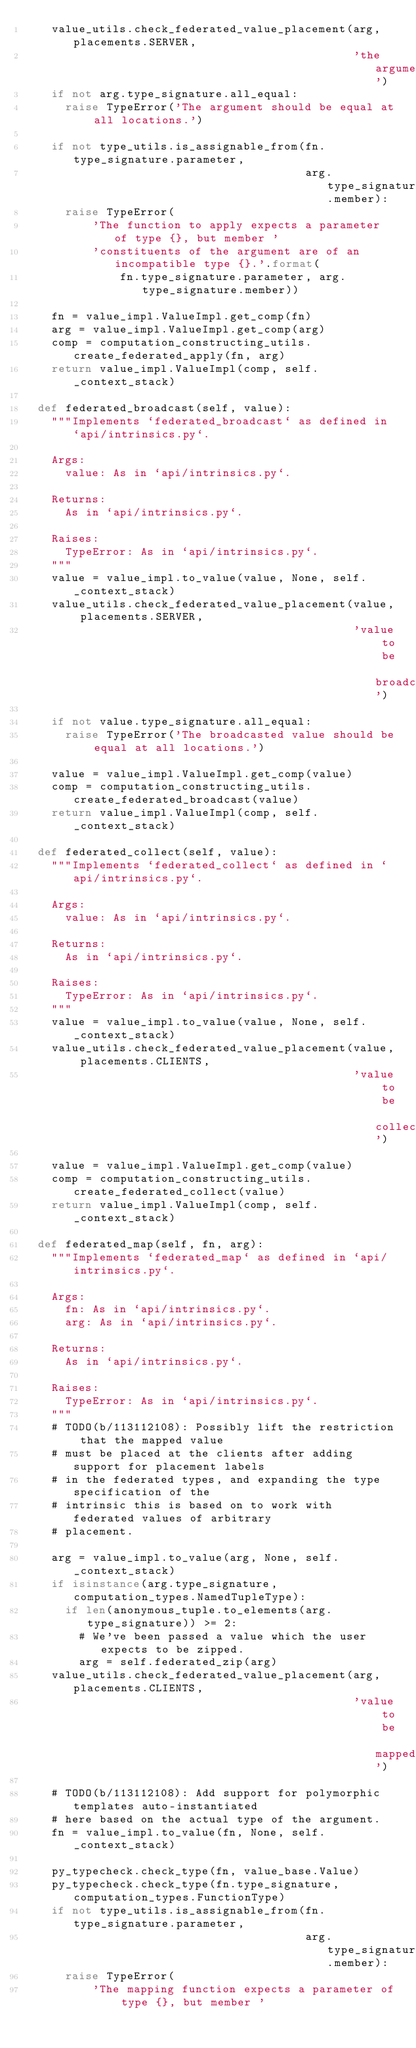<code> <loc_0><loc_0><loc_500><loc_500><_Python_>    value_utils.check_federated_value_placement(arg, placements.SERVER,
                                                'the argument')
    if not arg.type_signature.all_equal:
      raise TypeError('The argument should be equal at all locations.')

    if not type_utils.is_assignable_from(fn.type_signature.parameter,
                                         arg.type_signature.member):
      raise TypeError(
          'The function to apply expects a parameter of type {}, but member '
          'constituents of the argument are of an incompatible type {}.'.format(
              fn.type_signature.parameter, arg.type_signature.member))

    fn = value_impl.ValueImpl.get_comp(fn)
    arg = value_impl.ValueImpl.get_comp(arg)
    comp = computation_constructing_utils.create_federated_apply(fn, arg)
    return value_impl.ValueImpl(comp, self._context_stack)

  def federated_broadcast(self, value):
    """Implements `federated_broadcast` as defined in `api/intrinsics.py`.

    Args:
      value: As in `api/intrinsics.py`.

    Returns:
      As in `api/intrinsics.py`.

    Raises:
      TypeError: As in `api/intrinsics.py`.
    """
    value = value_impl.to_value(value, None, self._context_stack)
    value_utils.check_federated_value_placement(value, placements.SERVER,
                                                'value to be broadcasted')

    if not value.type_signature.all_equal:
      raise TypeError('The broadcasted value should be equal at all locations.')

    value = value_impl.ValueImpl.get_comp(value)
    comp = computation_constructing_utils.create_federated_broadcast(value)
    return value_impl.ValueImpl(comp, self._context_stack)

  def federated_collect(self, value):
    """Implements `federated_collect` as defined in `api/intrinsics.py`.

    Args:
      value: As in `api/intrinsics.py`.

    Returns:
      As in `api/intrinsics.py`.

    Raises:
      TypeError: As in `api/intrinsics.py`.
    """
    value = value_impl.to_value(value, None, self._context_stack)
    value_utils.check_federated_value_placement(value, placements.CLIENTS,
                                                'value to be collected')

    value = value_impl.ValueImpl.get_comp(value)
    comp = computation_constructing_utils.create_federated_collect(value)
    return value_impl.ValueImpl(comp, self._context_stack)

  def federated_map(self, fn, arg):
    """Implements `federated_map` as defined in `api/intrinsics.py`.

    Args:
      fn: As in `api/intrinsics.py`.
      arg: As in `api/intrinsics.py`.

    Returns:
      As in `api/intrinsics.py`.

    Raises:
      TypeError: As in `api/intrinsics.py`.
    """
    # TODO(b/113112108): Possibly lift the restriction that the mapped value
    # must be placed at the clients after adding support for placement labels
    # in the federated types, and expanding the type specification of the
    # intrinsic this is based on to work with federated values of arbitrary
    # placement.

    arg = value_impl.to_value(arg, None, self._context_stack)
    if isinstance(arg.type_signature, computation_types.NamedTupleType):
      if len(anonymous_tuple.to_elements(arg.type_signature)) >= 2:
        # We've been passed a value which the user expects to be zipped.
        arg = self.federated_zip(arg)
    value_utils.check_federated_value_placement(arg, placements.CLIENTS,
                                                'value to be mapped')

    # TODO(b/113112108): Add support for polymorphic templates auto-instantiated
    # here based on the actual type of the argument.
    fn = value_impl.to_value(fn, None, self._context_stack)

    py_typecheck.check_type(fn, value_base.Value)
    py_typecheck.check_type(fn.type_signature, computation_types.FunctionType)
    if not type_utils.is_assignable_from(fn.type_signature.parameter,
                                         arg.type_signature.member):
      raise TypeError(
          'The mapping function expects a parameter of type {}, but member '</code> 